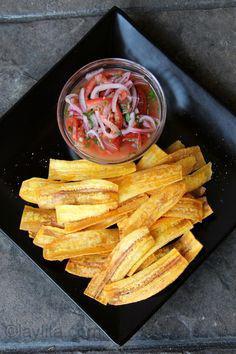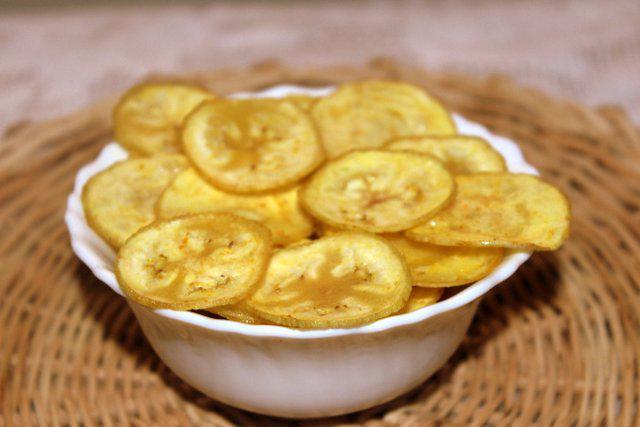The first image is the image on the left, the second image is the image on the right. Given the left and right images, does the statement "The left image shows a fried treat served on a dark plate, with something in a smaller bowl nearby." hold true? Answer yes or no. Yes. The first image is the image on the left, the second image is the image on the right. Assess this claim about the two images: "The chips in the image on the left are served with a side of red dipping sauce.". Correct or not? Answer yes or no. Yes. 